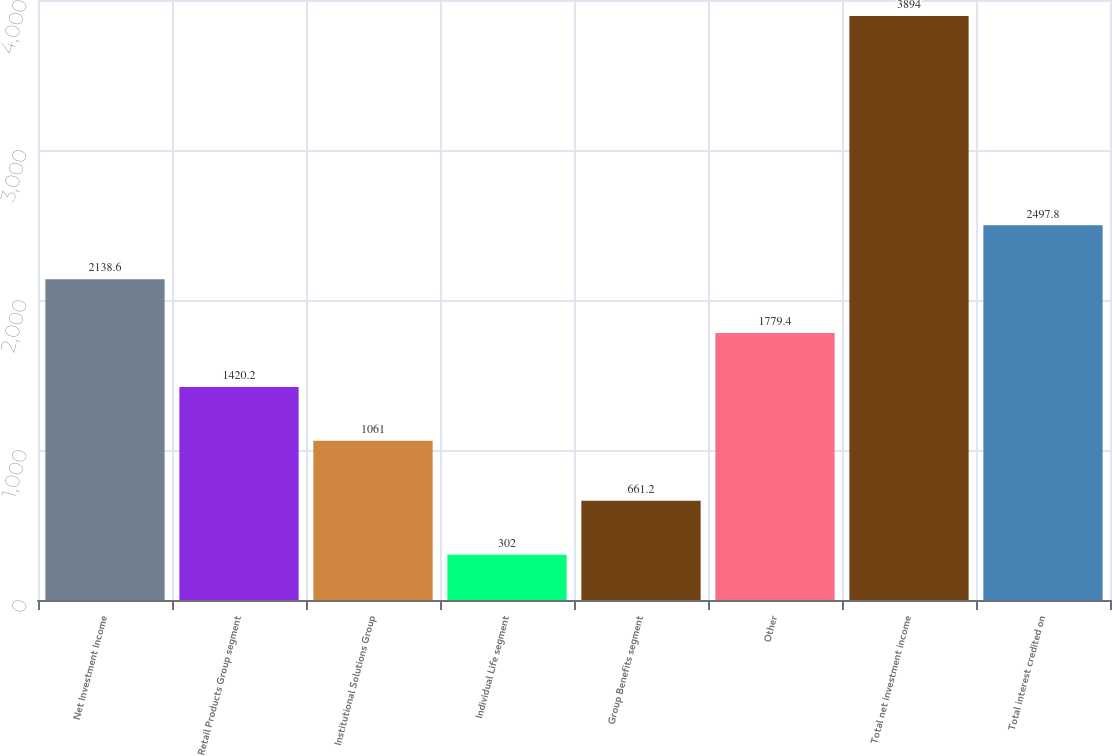Convert chart to OTSL. <chart><loc_0><loc_0><loc_500><loc_500><bar_chart><fcel>Net Investment Income<fcel>Retail Products Group segment<fcel>Institutional Solutions Group<fcel>Individual Life segment<fcel>Group Benefits segment<fcel>Other<fcel>Total net investment income<fcel>Total interest credited on<nl><fcel>2138.6<fcel>1420.2<fcel>1061<fcel>302<fcel>661.2<fcel>1779.4<fcel>3894<fcel>2497.8<nl></chart> 